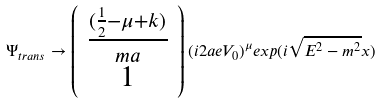Convert formula to latex. <formula><loc_0><loc_0><loc_500><loc_500>\Psi _ { t r a n s } \rightarrow \left ( \begin{array} { c c c } \frac { ( \frac { 1 } { 2 } - \mu + k ) } { m a } \\ 1 \\ \end{array} \right ) ( i 2 a e V _ { 0 } ) ^ { \mu } e x p ( i \sqrt { E ^ { 2 } - m ^ { 2 } } x )</formula> 